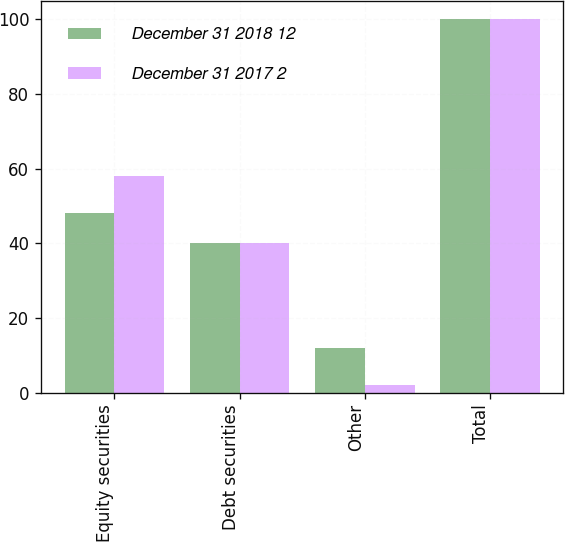Convert chart. <chart><loc_0><loc_0><loc_500><loc_500><stacked_bar_chart><ecel><fcel>Equity securities<fcel>Debt securities<fcel>Other<fcel>Total<nl><fcel>December 31 2018 12<fcel>48<fcel>40<fcel>12<fcel>100<nl><fcel>December 31 2017 2<fcel>58<fcel>40<fcel>2<fcel>100<nl></chart> 